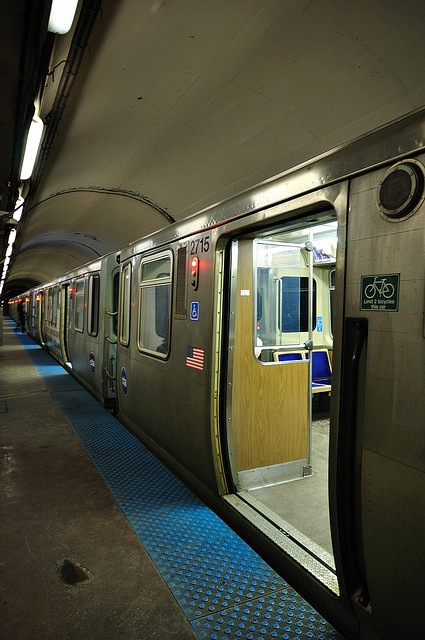Describe the objects in this image and their specific colors. I can see train in black, gray, darkgreen, and darkgray tones, chair in black, navy, darkblue, and khaki tones, and bicycle in black, gray, and darkgreen tones in this image. 